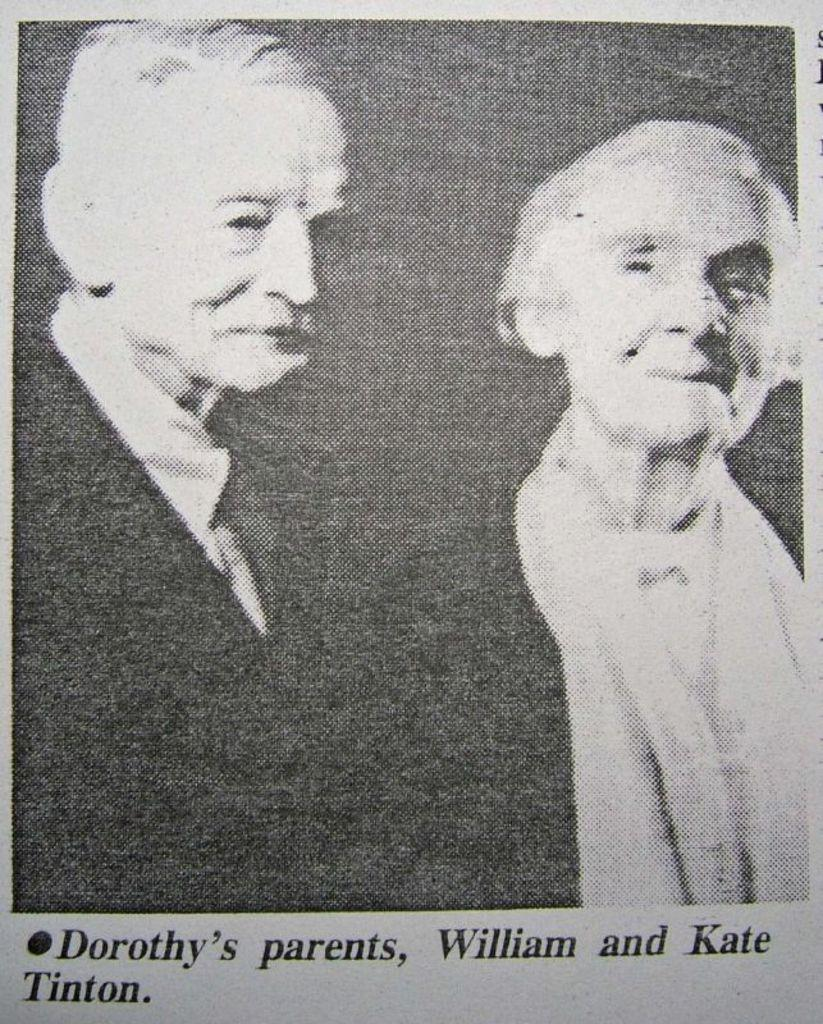How many people are present in the image? There are two persons in the image. What can be seen in addition to the people in the image? There is text written on the image. What is the color scheme of the image? The image is in black and white. What type of pot is hanging from the swing in the image? There is no pot or swing present in the image; it only features two persons and text. 